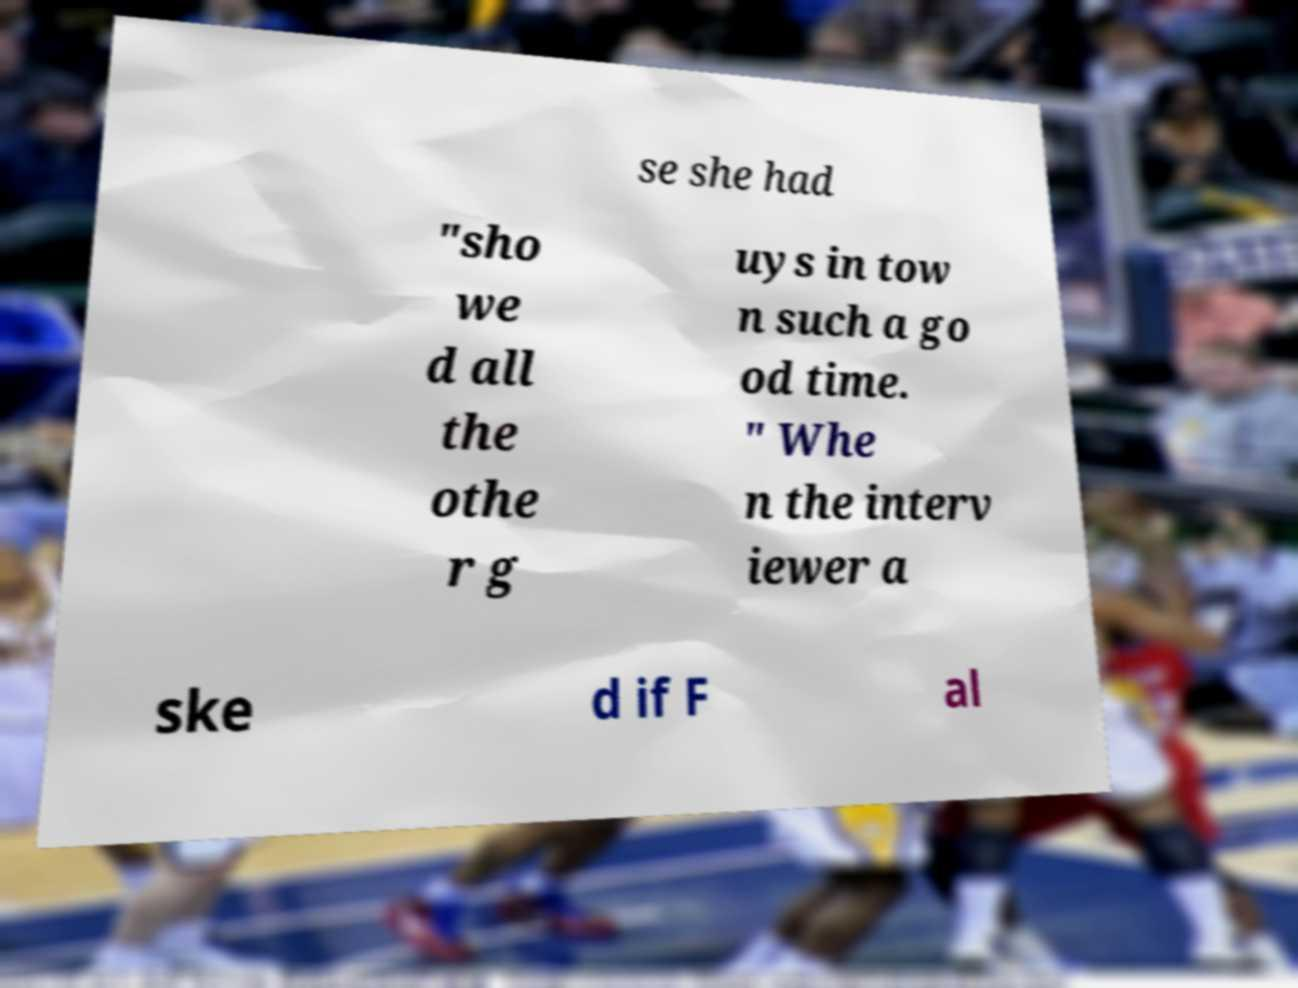I need the written content from this picture converted into text. Can you do that? se she had "sho we d all the othe r g uys in tow n such a go od time. " Whe n the interv iewer a ske d if F al 